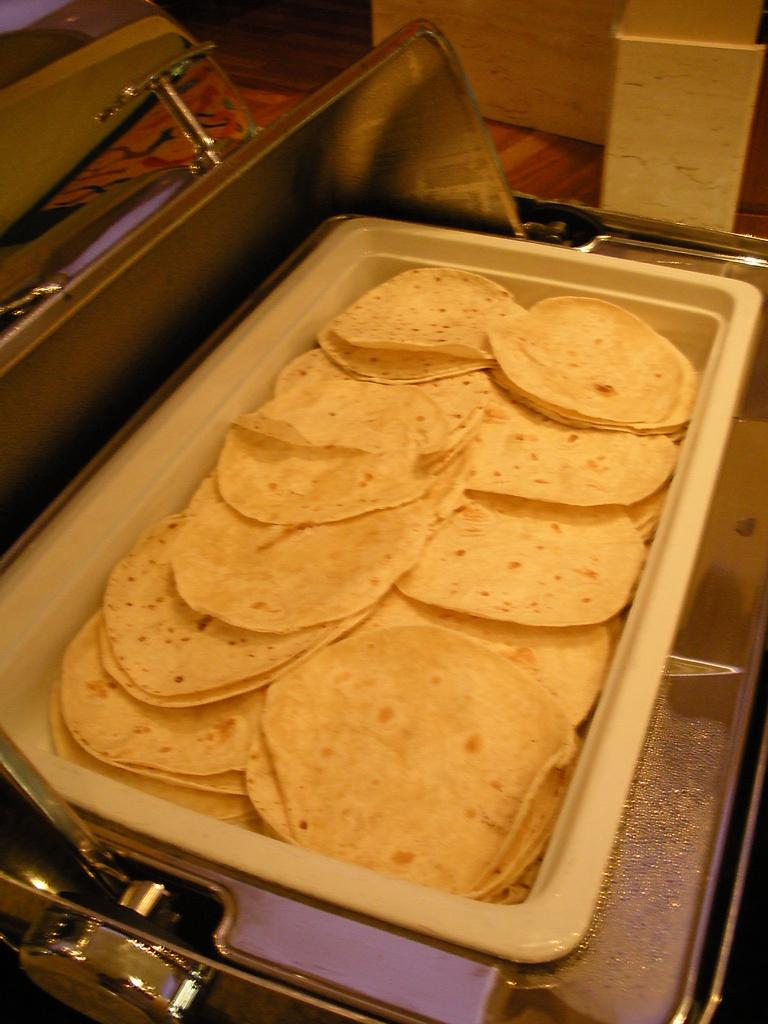What type of food is visible in the image? There are chapatis in a tray in the image. What is used to cover the tray in the image? There is a covering lid in the image. How many quinces are present in the image? There are no quinces present in the image. What type of animal can be seen interacting with the chapatis in the image? There are no animals, including cats, present in the image. 